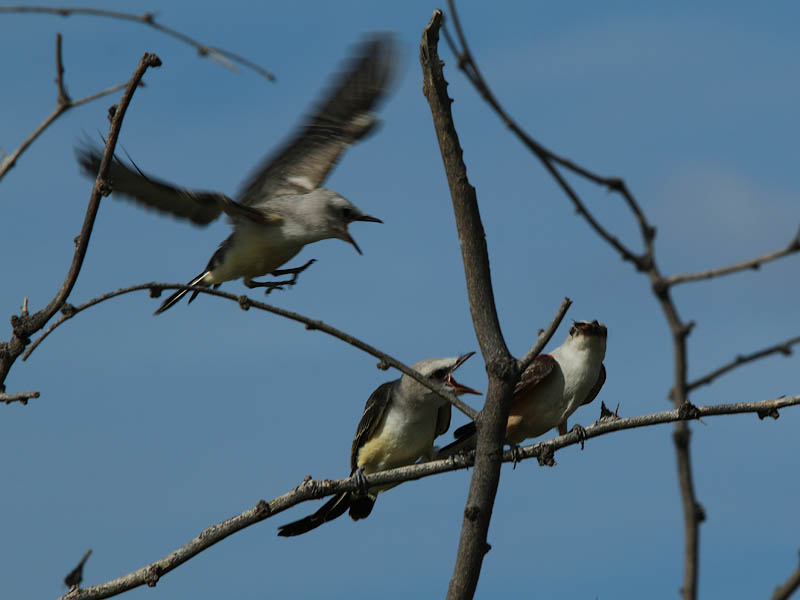What time of day do birds like these usually engage in feeding activity, and could this image give any hint of that timing? Many bird species engage in feeding during the early morning and late afternoon, taking advantage of cooler temperatures and reduced predator activity. This image, with its clear blue sky and the quality of light, may suggest morning or late afternoon. However, without distinct shadow lengths or sun position, the exact timing within these periods is difficult to determine. 